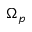Convert formula to latex. <formula><loc_0><loc_0><loc_500><loc_500>\Omega _ { p }</formula> 